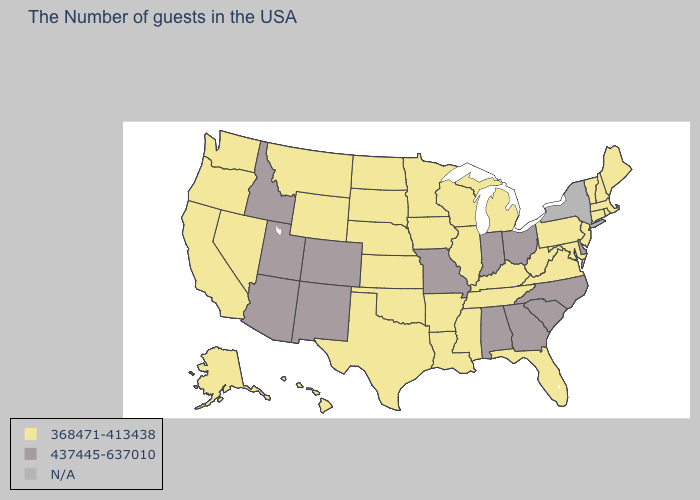Name the states that have a value in the range N/A?
Keep it brief. New York. Which states have the lowest value in the USA?
Keep it brief. Maine, Massachusetts, Rhode Island, New Hampshire, Vermont, Connecticut, New Jersey, Maryland, Pennsylvania, Virginia, West Virginia, Florida, Michigan, Kentucky, Tennessee, Wisconsin, Illinois, Mississippi, Louisiana, Arkansas, Minnesota, Iowa, Kansas, Nebraska, Oklahoma, Texas, South Dakota, North Dakota, Wyoming, Montana, Nevada, California, Washington, Oregon, Alaska, Hawaii. Name the states that have a value in the range 368471-413438?
Answer briefly. Maine, Massachusetts, Rhode Island, New Hampshire, Vermont, Connecticut, New Jersey, Maryland, Pennsylvania, Virginia, West Virginia, Florida, Michigan, Kentucky, Tennessee, Wisconsin, Illinois, Mississippi, Louisiana, Arkansas, Minnesota, Iowa, Kansas, Nebraska, Oklahoma, Texas, South Dakota, North Dakota, Wyoming, Montana, Nevada, California, Washington, Oregon, Alaska, Hawaii. Name the states that have a value in the range 368471-413438?
Concise answer only. Maine, Massachusetts, Rhode Island, New Hampshire, Vermont, Connecticut, New Jersey, Maryland, Pennsylvania, Virginia, West Virginia, Florida, Michigan, Kentucky, Tennessee, Wisconsin, Illinois, Mississippi, Louisiana, Arkansas, Minnesota, Iowa, Kansas, Nebraska, Oklahoma, Texas, South Dakota, North Dakota, Wyoming, Montana, Nevada, California, Washington, Oregon, Alaska, Hawaii. What is the highest value in the MidWest ?
Write a very short answer. 437445-637010. What is the lowest value in the USA?
Be succinct. 368471-413438. Does Oregon have the lowest value in the USA?
Quick response, please. Yes. What is the value of Michigan?
Answer briefly. 368471-413438. Among the states that border Minnesota , which have the highest value?
Give a very brief answer. Wisconsin, Iowa, South Dakota, North Dakota. Among the states that border Maryland , which have the highest value?
Short answer required. Delaware. Does the first symbol in the legend represent the smallest category?
Answer briefly. Yes. What is the lowest value in states that border Delaware?
Keep it brief. 368471-413438. 